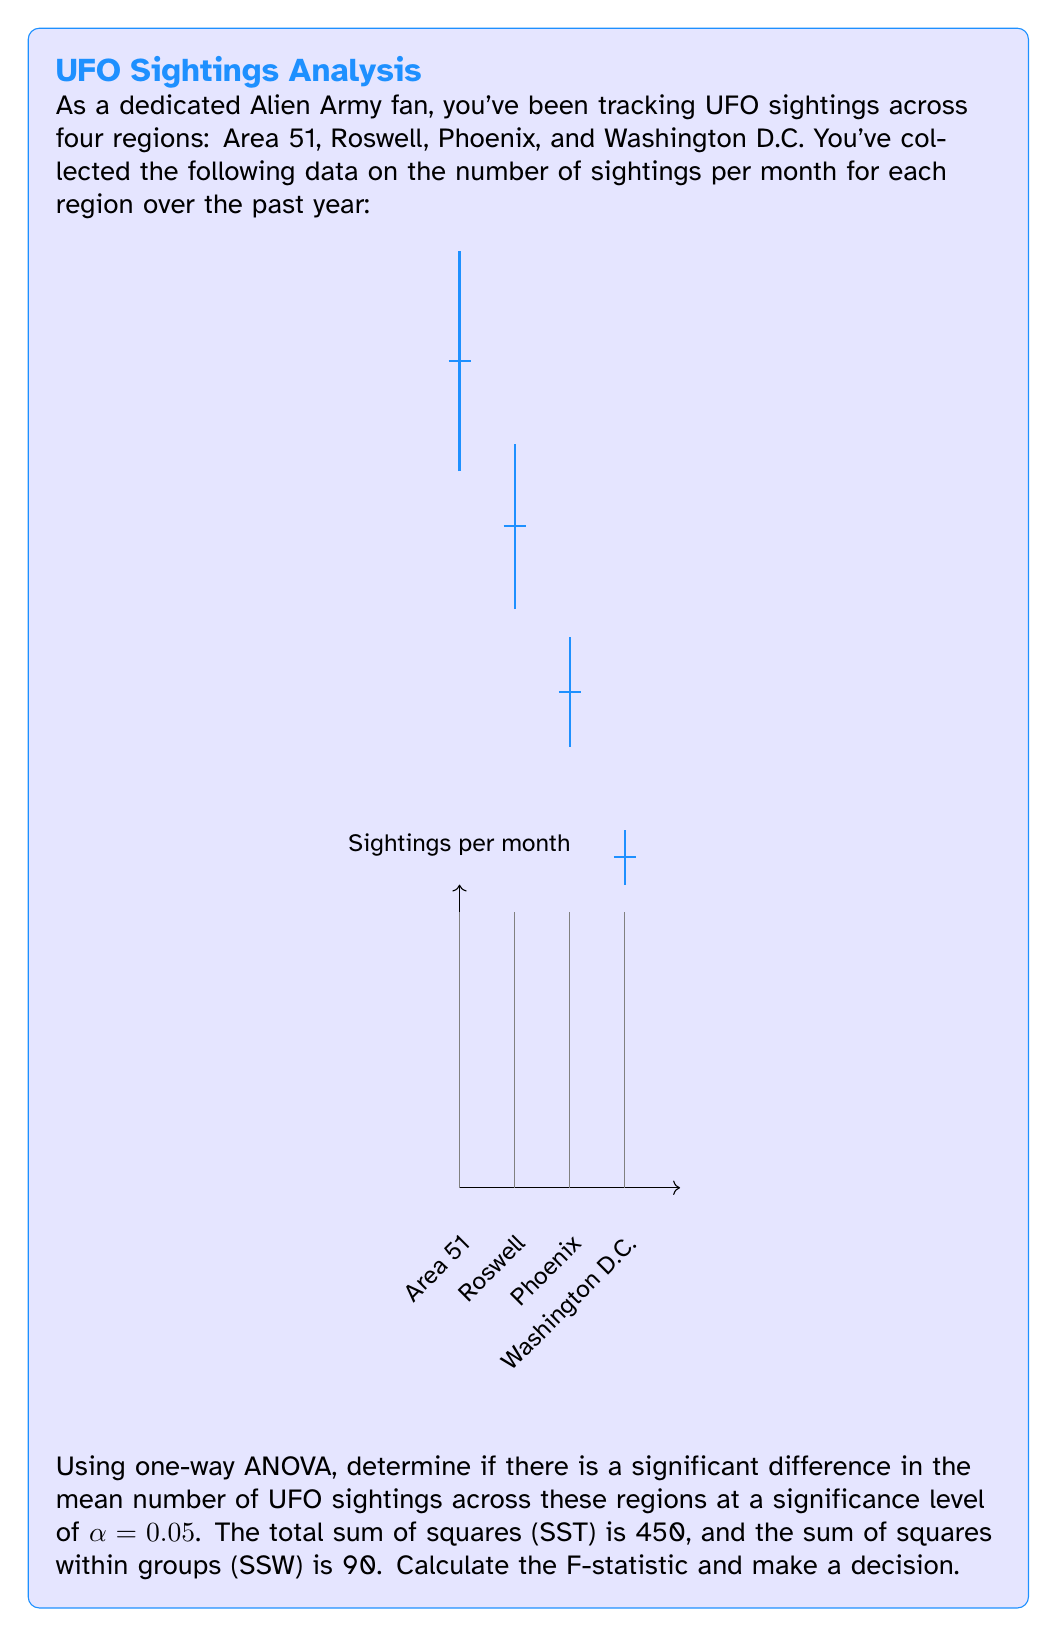What is the answer to this math problem? Let's approach this step-by-step:

1) First, we need to calculate the degrees of freedom:
   - Total df = n - 1, where n is the total number of observations
   - Between groups df = k - 1, where k is the number of groups (regions)
   - Within groups df = n - k

   We have 4 regions, so k = 4. Let's assume we have 12 months of data for each region, so n = 4 * 12 = 48.

   Total df = 48 - 1 = 47
   Between groups df = 4 - 1 = 3
   Within groups df = 48 - 4 = 44

2) Calculate the sum of squares between groups (SSB):
   SSB = SST - SSW = 450 - 90 = 360

3) Calculate the mean squares:
   MSB = SSB / df_between = 360 / 3 = 120
   MSW = SSW / df_within = 90 / 44 ≈ 2.045

4) Calculate the F-statistic:
   $$F = \frac{MSB}{MSW} = \frac{120}{2.045} \approx 58.68$$

5) Find the critical F-value:
   For α = 0.05, df_between = 3, and df_within = 44, the critical F-value is approximately 2.82 (from an F-distribution table).

6) Decision rule:
   If F > F_critical, reject the null hypothesis.
   58.68 > 2.82, so we reject the null hypothesis.
Answer: F ≈ 58.68; Reject null hypothesis; significant difference in mean UFO sightings across regions. 